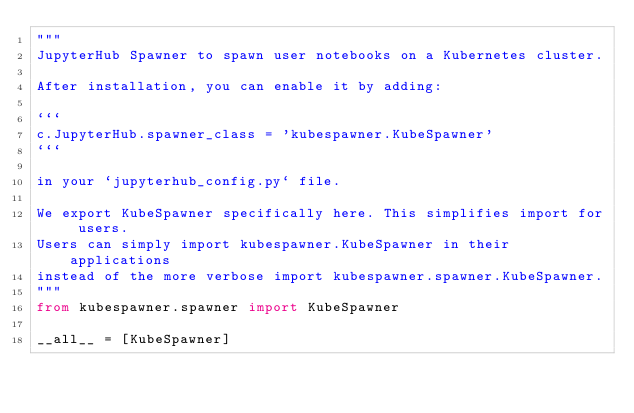<code> <loc_0><loc_0><loc_500><loc_500><_Python_>"""
JupyterHub Spawner to spawn user notebooks on a Kubernetes cluster.

After installation, you can enable it by adding:

```
c.JupyterHub.spawner_class = 'kubespawner.KubeSpawner'
```

in your `jupyterhub_config.py` file.

We export KubeSpawner specifically here. This simplifies import for users.
Users can simply import kubespawner.KubeSpawner in their applications
instead of the more verbose import kubespawner.spawner.KubeSpawner.
"""
from kubespawner.spawner import KubeSpawner

__all__ = [KubeSpawner]
</code> 